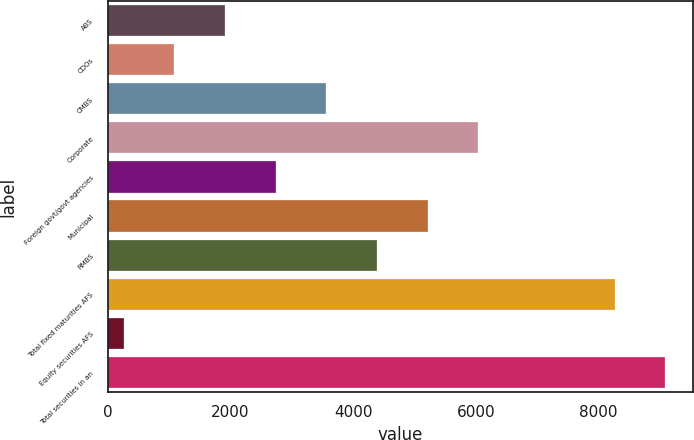<chart> <loc_0><loc_0><loc_500><loc_500><bar_chart><fcel>ABS<fcel>CDOs<fcel>CMBS<fcel>Corporate<fcel>Foreign govt/govt agencies<fcel>Municipal<fcel>RMBS<fcel>Total fixed maturities AFS<fcel>Equity securities AFS<fcel>Total securities in an<nl><fcel>1911<fcel>1084.5<fcel>3564<fcel>6043.5<fcel>2737.5<fcel>5217<fcel>4390.5<fcel>8265<fcel>258<fcel>9091.5<nl></chart> 